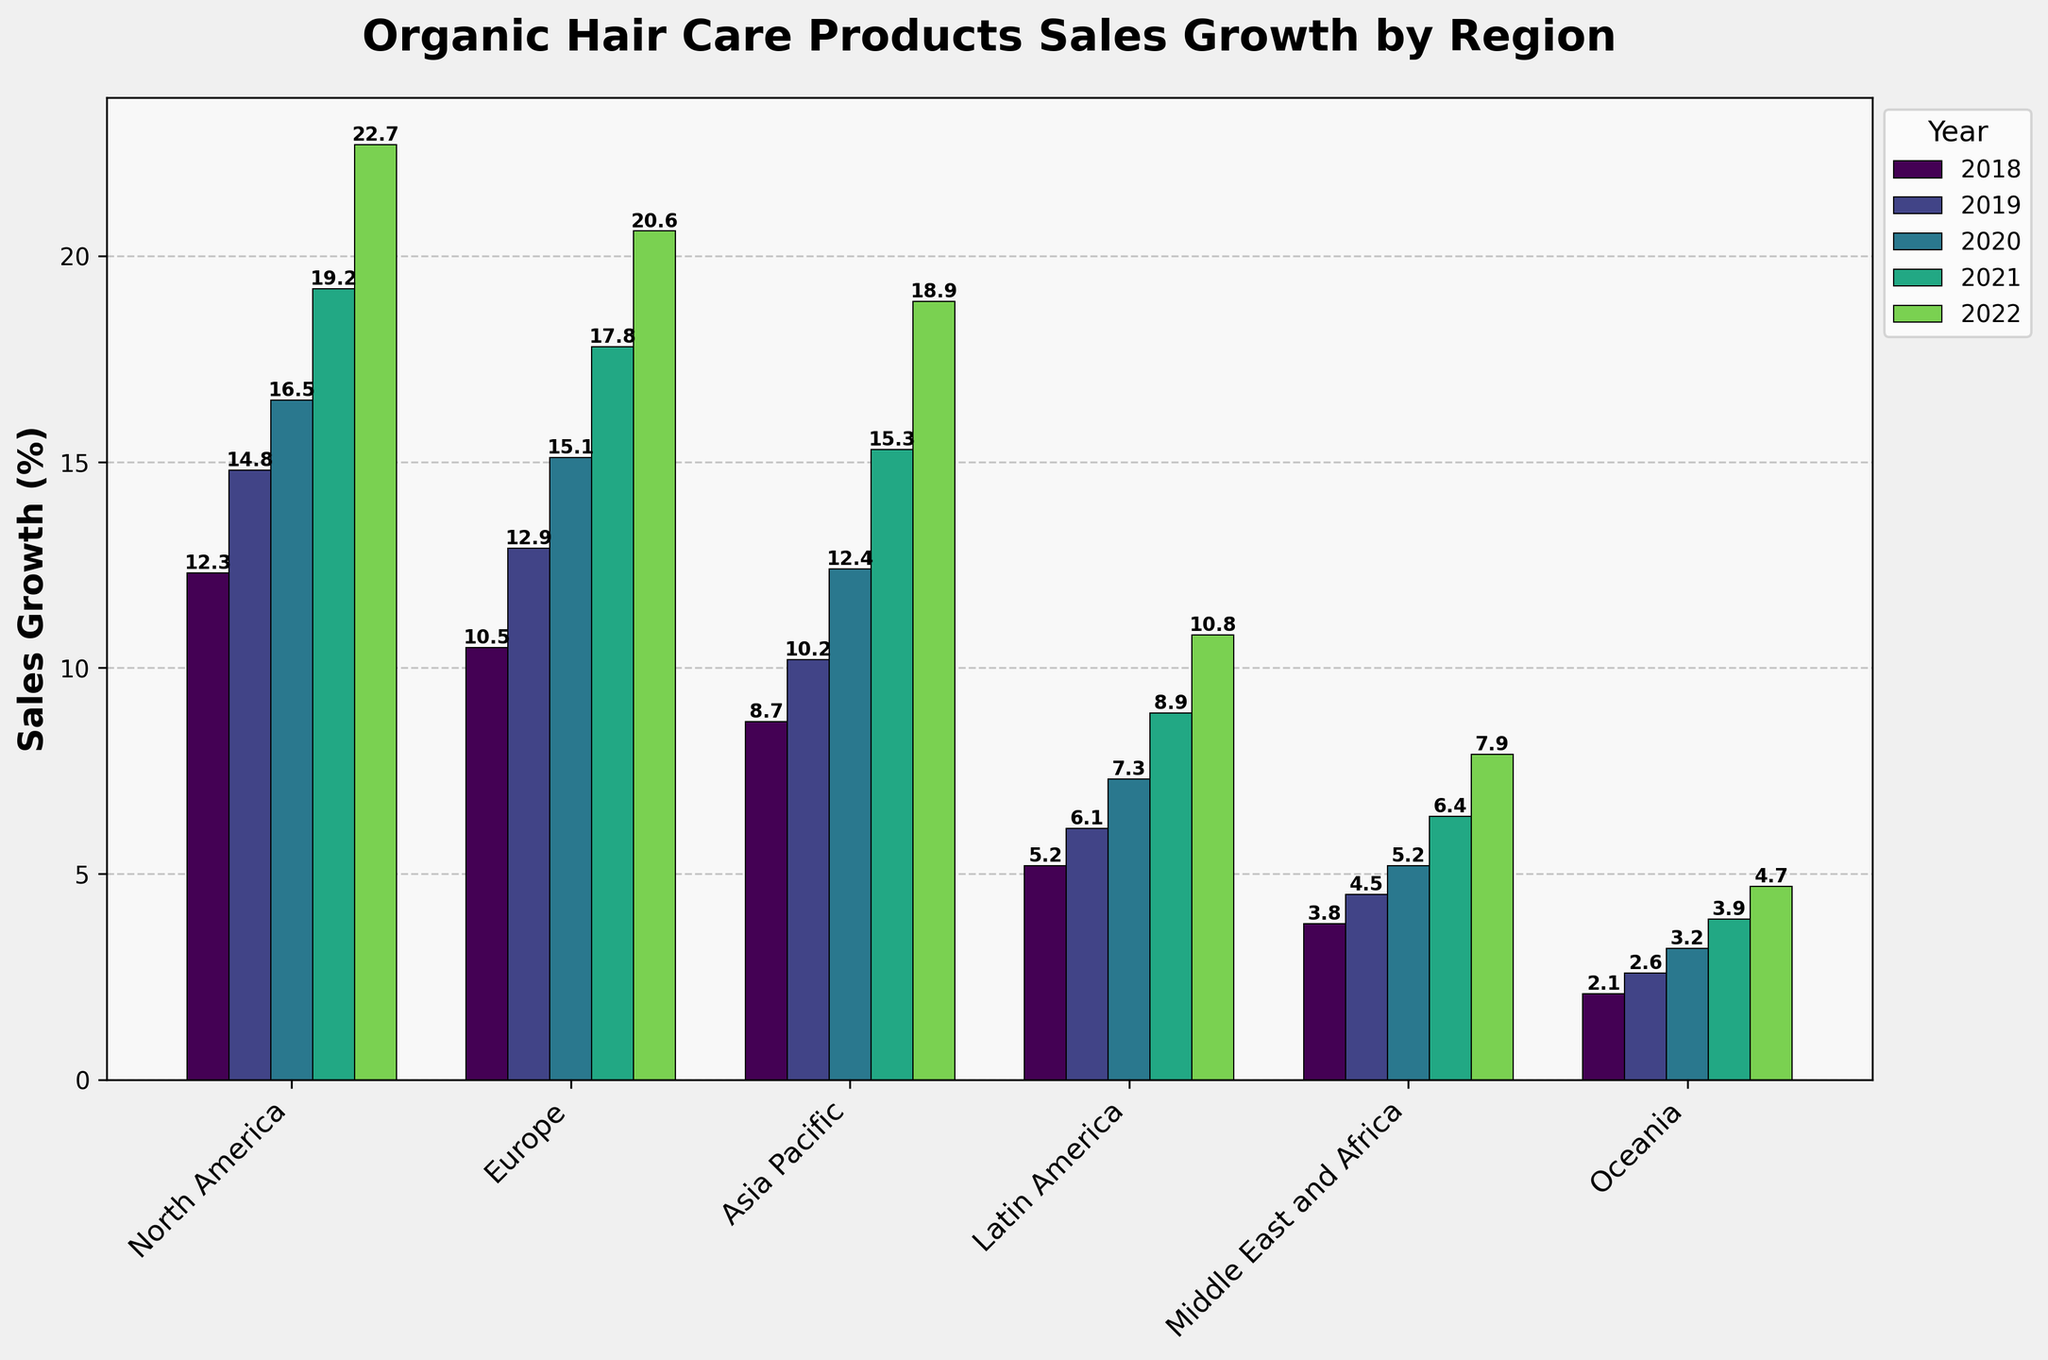What region had the highest sales growth in 2022? Look at the bars corresponding to 2022 and identify the tallest one, which represents the highest sales growth.
Answer: North America Which region showed the lowest sales growth in 2018? Check the 2018 bars and look for the shortest one, indicating the lowest sales growth.
Answer: Oceania Did any region experience a decline in sales growth over the 5 years? Analyze the trend for each region from 2018 to 2022 to see if any bars decrease over the years. All regions show an upward trend without any decline.
Answer: No What is the average sales growth in North America over the 5 years? Sum up the sales growth values for North America from 2018 to 2022 and divide by the number of years: (12.3 + 14.8 + 16.5 + 19.2 + 22.7)/5 = 85.5/5
Answer: 17.1 Which year showed the highest overall growth across all regions? For each year, sum the sales growth numbers of all regions and compare to find the highest total. The sums are 42.6 (2018), 51.1 (2019), 60.2 (2020), 71.5 (2021), 85.6 (2022). The highest is 2022.
Answer: 2022 Compare the sales growth between Europe and Asia Pacific in 2020. Which one was higher? Look at the bars for Europe and Asia Pacific in 2020 and compare their heights.
Answer: Europe How much did sales growth increase in Latin America from 2018 to 2021? Subtract the 2018 value for Latin America from the 2021 value: 8.9 - 5.2 = 3.7
Answer: 3.7 Which region had a consistent increase in sales growth every year? Examine the trend for each region; consistent growth means each year's value is higher than the previous year’s. Every region shows consistent growth.
Answer: All regions What's the difference in sales growth between North America and Oceania in 2022? Subtract the 2022 value for Oceania from the 2022 value for North America: 22.7 - 4.7 = 18
Answer: 18 Which region had the steepest increase in sales growth from 2018 to 2022? Calculate the increase for each region by subtracting 2018 values from 2022 values, then compare: North America (22.7 - 12.3 = 10.4), Europe (20.6 - 10.5 = 10.1), Asia Pacific (18.9 - 8.7 = 10.2), Latin America (10.8 - 5.2 = 5.6), Middle East and Africa (7.9 - 3.8 = 4.1), Oceania (4.7 - 2.1 = 2.6). The steepest increase is in North America.
Answer: North America 